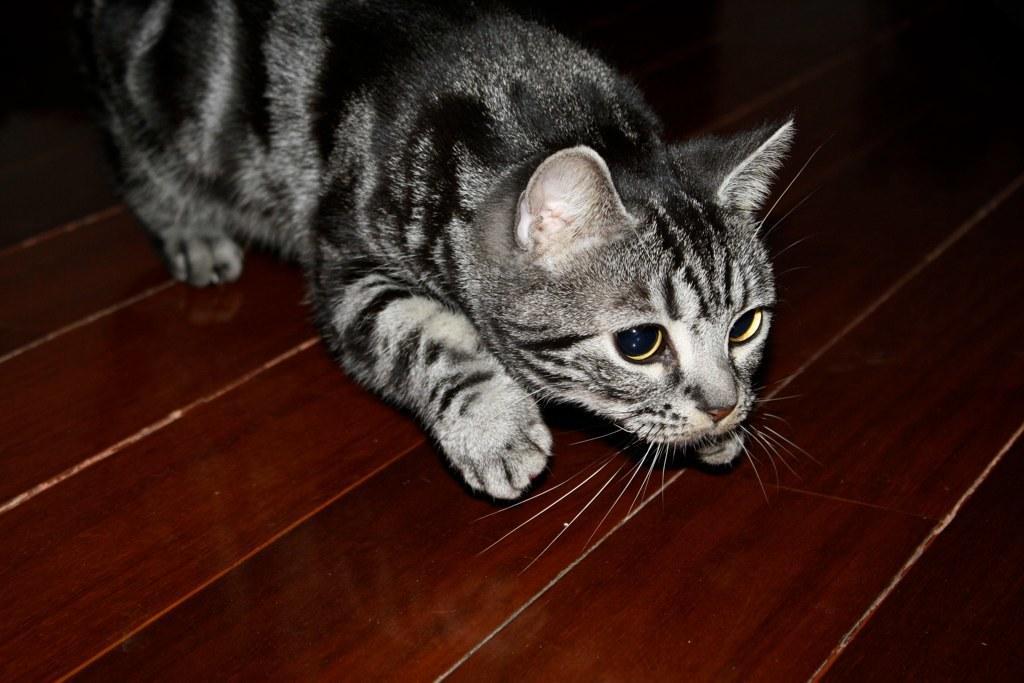Describe this image in one or two sentences. In this image I can see brown colour surface and on it I can see a grey colour cat. 